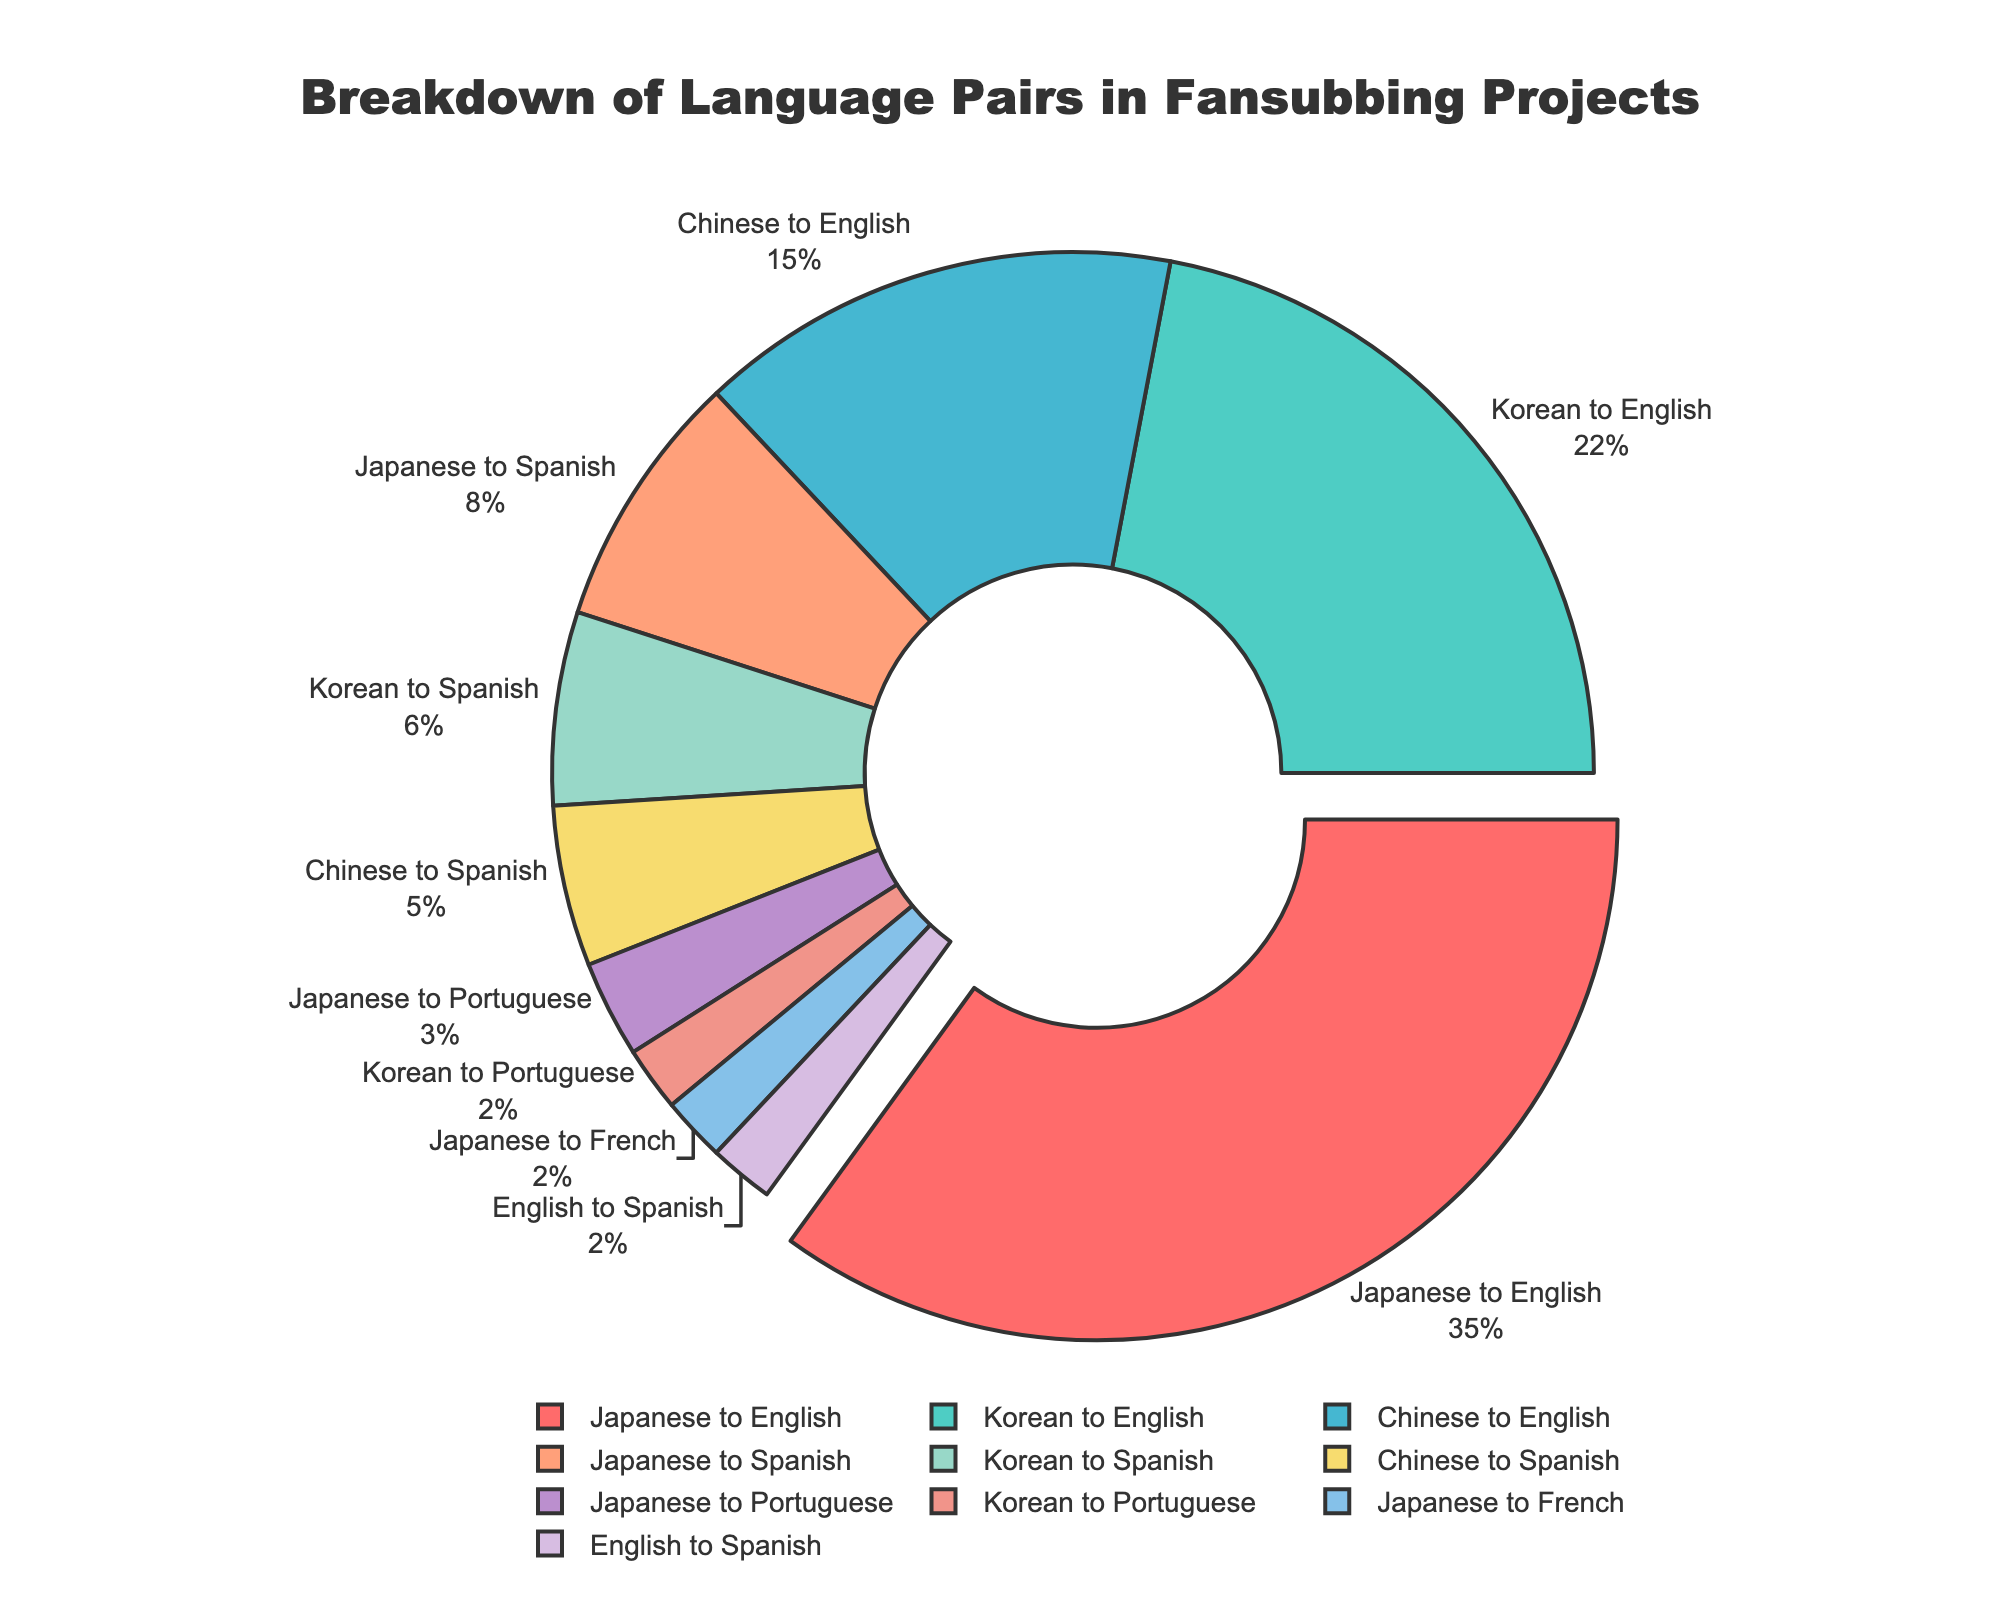Which language pair has the highest percentage in fansubbing projects? The Japanese to English language pair has the highest percentage in the fansubbing projects as it occupies the largest segment in the pie chart.
Answer: Japanese to English How many language pairs are in the pie chart? By counting the segments in the pie chart, there are 10 language pairs represented.
Answer: 10 Is the percentage of Chinese to English greater than the combined percentage of Japanese to Spanish and Korean to Spanish? The percentage of Chinese to English is 15%. The combined percentage of Japanese to Spanish (8%) and Korean to Spanish (6%) is 14%. Since 15% > 14%, Chinese to English is indeed greater.
Answer: Yes What is the combined percentage of language pairs translating into Spanish? To find the combined percentage, add Japanese to Spanish (8%), Korean to Spanish (6%), Chinese to Spanish (5%), and English to Spanish (2%). Summing these gives 8% + 6% + 5% + 2% = 21%.
Answer: 21% Which segment of the pie chart is pulled out? The Japanese to English segment is pulled out as seen in the visual representation with the pie slice being slightly separated from the rest.
Answer: Japanese to English Compare the percentages of Korean to English and Chinese to English. Which one is greater and by how much? The Korean to English percentage is 22%, while the Chinese to English percentage is 15%. The difference is 22% - 15% = 7%. So, Korean to English is greater by 7%.
Answer: Korean to English, by 7% What percentage do the Japanese to Portuguese and the Korean to Portuguese language pairs together form? Adding the Japanese to Portuguese percentage (3%) and the Korean to Portuguese percentage (2%), we get 3% + 2% = 5%.
Answer: 5% Which three language pairs have the smallest percentages, and what are their percentages? The three smallest percentages are Japanese to French, Korean to Portuguese, and English to Spanish, each with 2%.
Answer: Japanese to French: 2%, Korean to Portuguese: 2%, English to Spanish: 2% What percentage of the fansubbing projects do the translations from Asian languages to English cover? Adding Japanese to English (35%), Korean to English (22%), and Chinese to English (15%), results in 35% + 22% + 15% = 72%.
Answer: 72% 